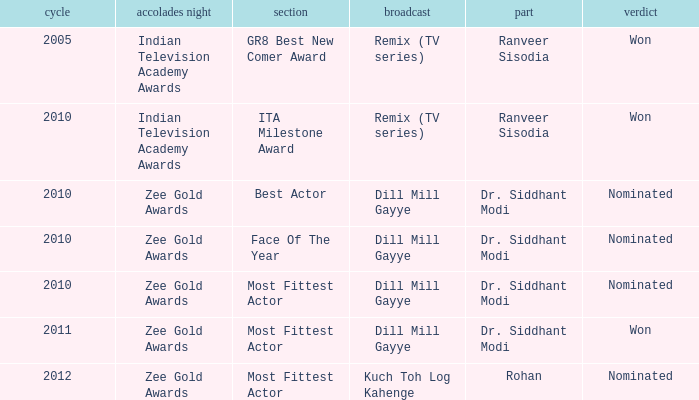Which show has a character of Rohan? Kuch Toh Log Kahenge. 